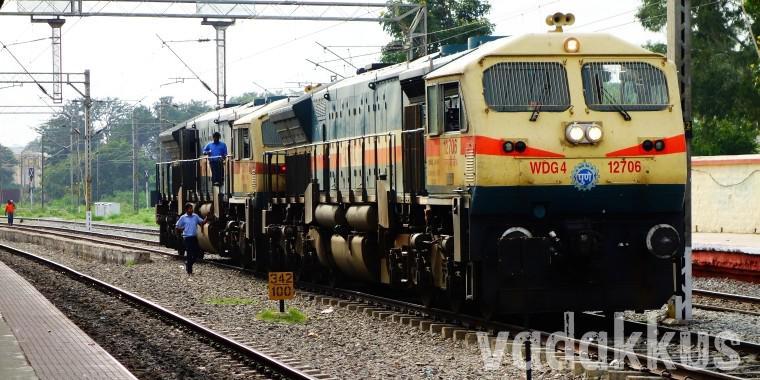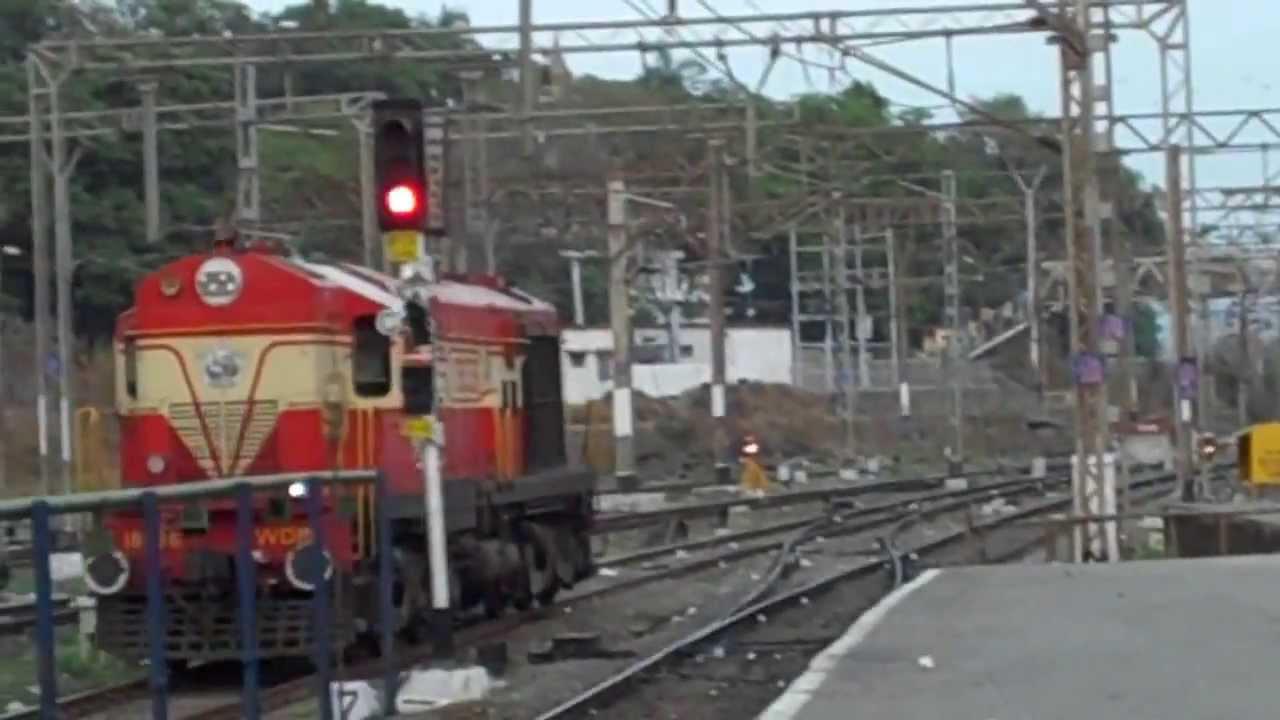The first image is the image on the left, the second image is the image on the right. Given the left and right images, does the statement "A train in one image is red with two grated windows on the front and a narrow yellow band encircling the car." hold true? Answer yes or no. No. 